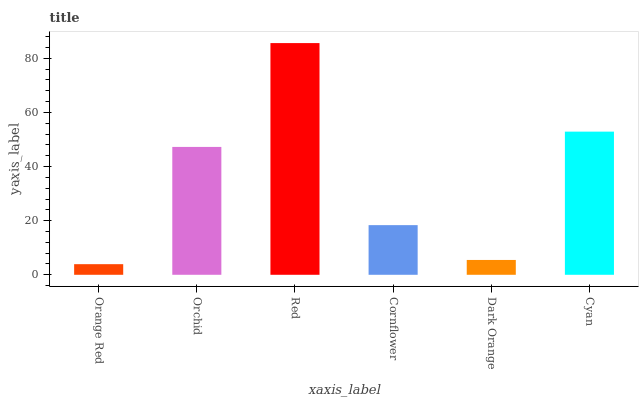Is Orange Red the minimum?
Answer yes or no. Yes. Is Red the maximum?
Answer yes or no. Yes. Is Orchid the minimum?
Answer yes or no. No. Is Orchid the maximum?
Answer yes or no. No. Is Orchid greater than Orange Red?
Answer yes or no. Yes. Is Orange Red less than Orchid?
Answer yes or no. Yes. Is Orange Red greater than Orchid?
Answer yes or no. No. Is Orchid less than Orange Red?
Answer yes or no. No. Is Orchid the high median?
Answer yes or no. Yes. Is Cornflower the low median?
Answer yes or no. Yes. Is Cornflower the high median?
Answer yes or no. No. Is Orchid the low median?
Answer yes or no. No. 